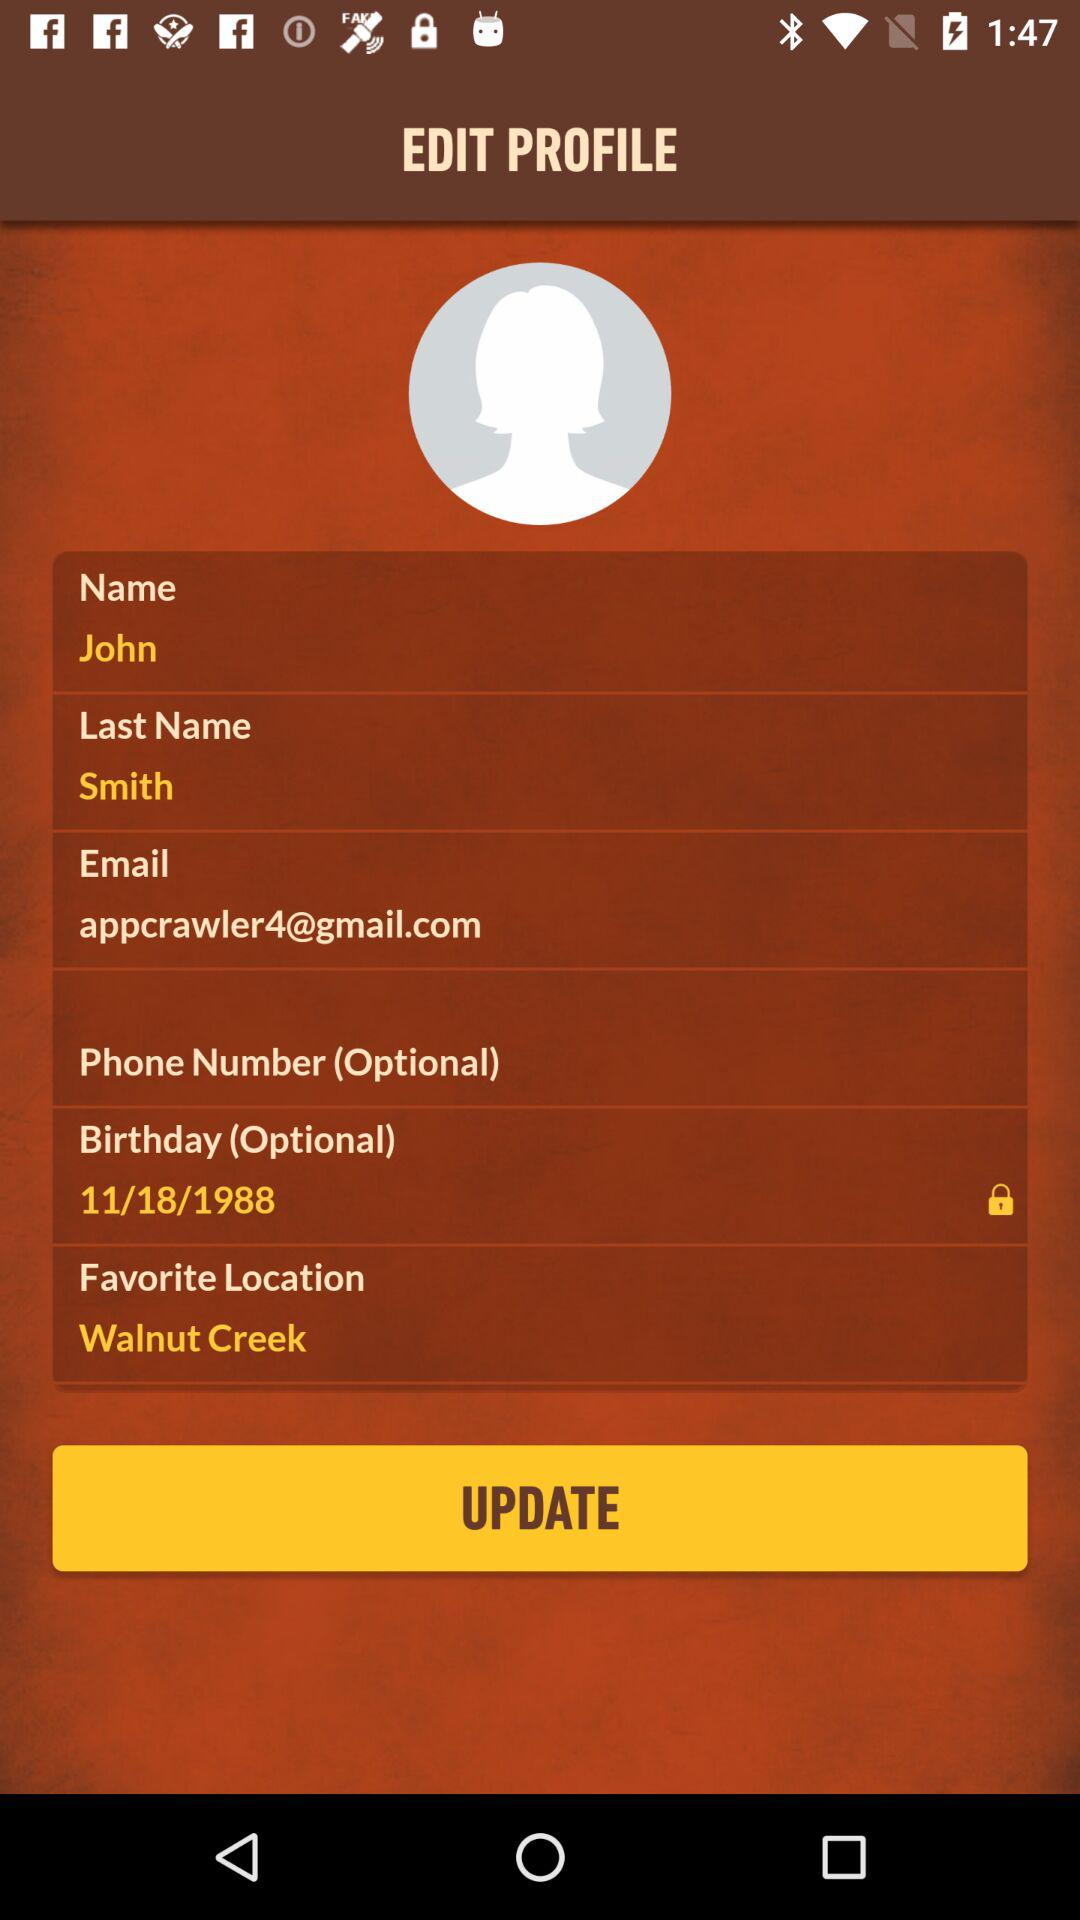How tall is John Smith?
When the provided information is insufficient, respond with <no answer>. <no answer> 